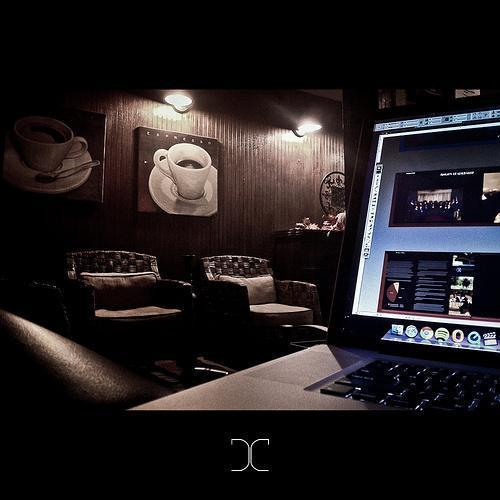How many chairs are there?
Give a very brief answer. 2. 